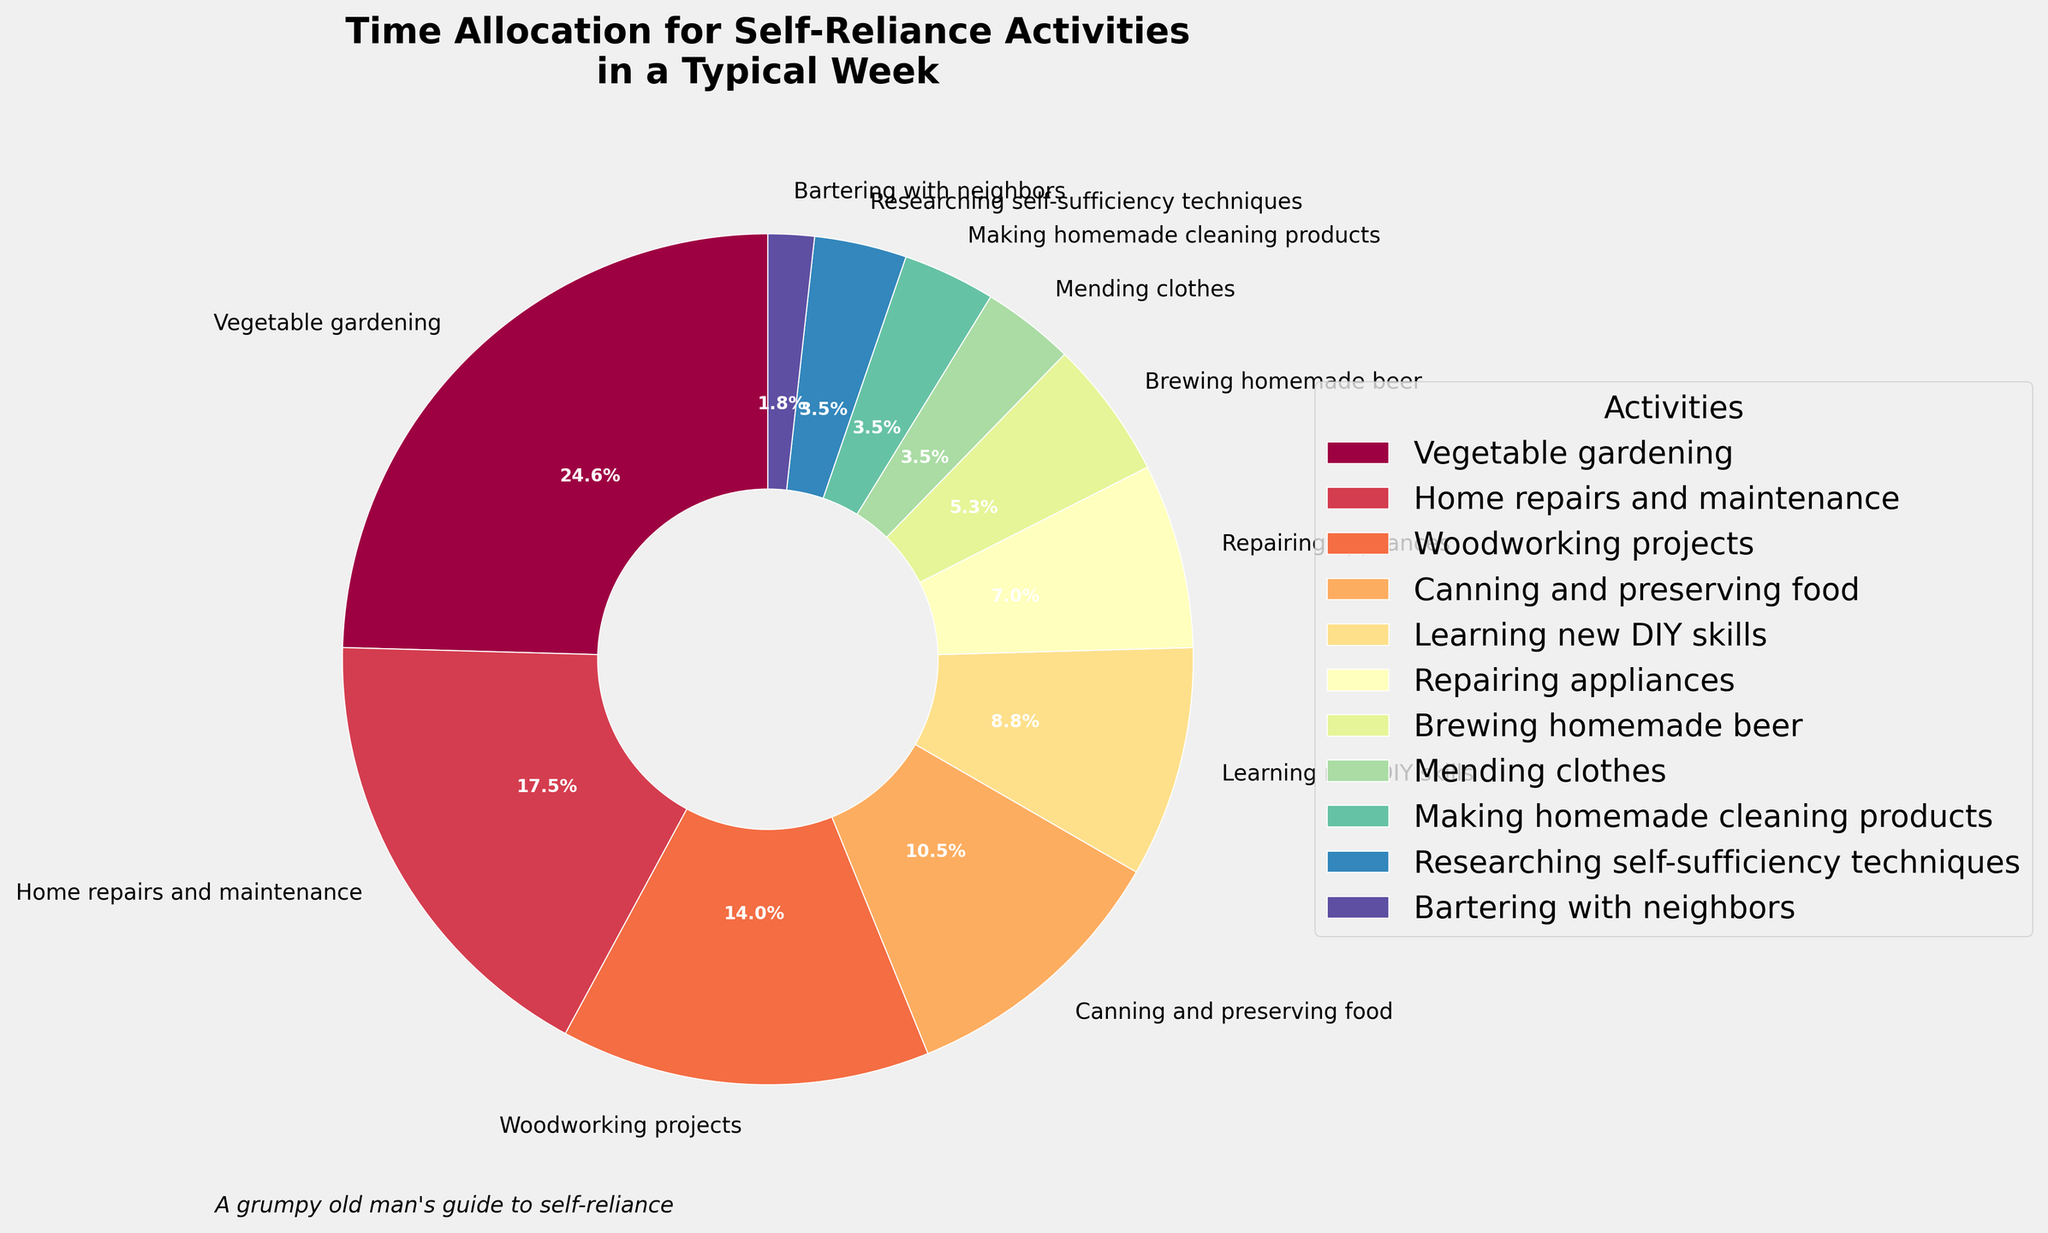Which activity takes up the most time? Look at the size of the wedges and the corresponding labels. The largest wedge corresponds to Vegetable gardening.
Answer: Vegetable gardening What percentage of the week is spent on Brewing homemade beer? Refer to the label next to the wedge for Brewing homemade beer. It directly shows the percentage.
Answer: 5.9% Which activities combined take up exactly half of the total time? Add the percentages of activities until the sum is 50%. Combining Vegetable gardening (20.6%) and Home repairs and maintenance (14.7%) gives 35.3%, adding Woodworking projects (11.8%) gives 47.1%, and finally, adding Canning and preserving food (8.8%) gives 55.9%, so we passed 50%. Instead, excluding Woodworking and including Learning new DIY skills (7.4%) gives exactly 50%.
Answer: Vegetable gardening, Home repairs and maintenance, Canning and preserving food, Learning new DIY skills Which activity takes up more time: Repairing appliances or Mending clothes? Compare the wedge sizes directly. Repairing appliances has a larger wedge than Mending clothes.
Answer: Repairing appliances How much more time is spent on Home repairs and maintenance compared to Brewing homemade beer? Subtract the hours of Brewing homemade beer from Home repairs and maintenance. 10 hours for Home repairs and maintenance minus 3 hours for Brewing homemade beer equals 7 hours.
Answer: 7 hours What is the combined percentage of time spent on Canning and preserving food and Making homemade cleaning products? Add the percentages of these two activities. Canning and preserving food (8.8%) plus Making homemade cleaning products (2.9%) equals 11.7%.
Answer: 11.7% What is the least time-consuming activity? Identify the smallest wedge from the pie chart. It corresponds to Bartering with neighbors.
Answer: Bartering with neighbors What is the total percentage of time spent on activities involving food? Activities involving food are Vegetable gardening, Canning and preserving food, and Brewing homemade beer. Add their percentages: 20.6% + 8.8% + 5.9% equals 35.3%.
Answer: 35.3% Which activity is almost equal in time to Learning new DIY skills, but slightly less? Compare the wedge sizes and percentages of activities around Learning new DIY skills (7.4%). Repairing appliances is slightly less with 5.9%.
Answer: Repairing appliances What is the difference in percentage between the most time-consuming and least time-consuming activities? Subtract the percentage of the least time-consuming activity (Bartering with neighbors: 1.5%) from the most time-consuming one (Vegetable gardening: 20.6%). 20.6% - 1.5% equals 19.1%.
Answer: 19.1% 